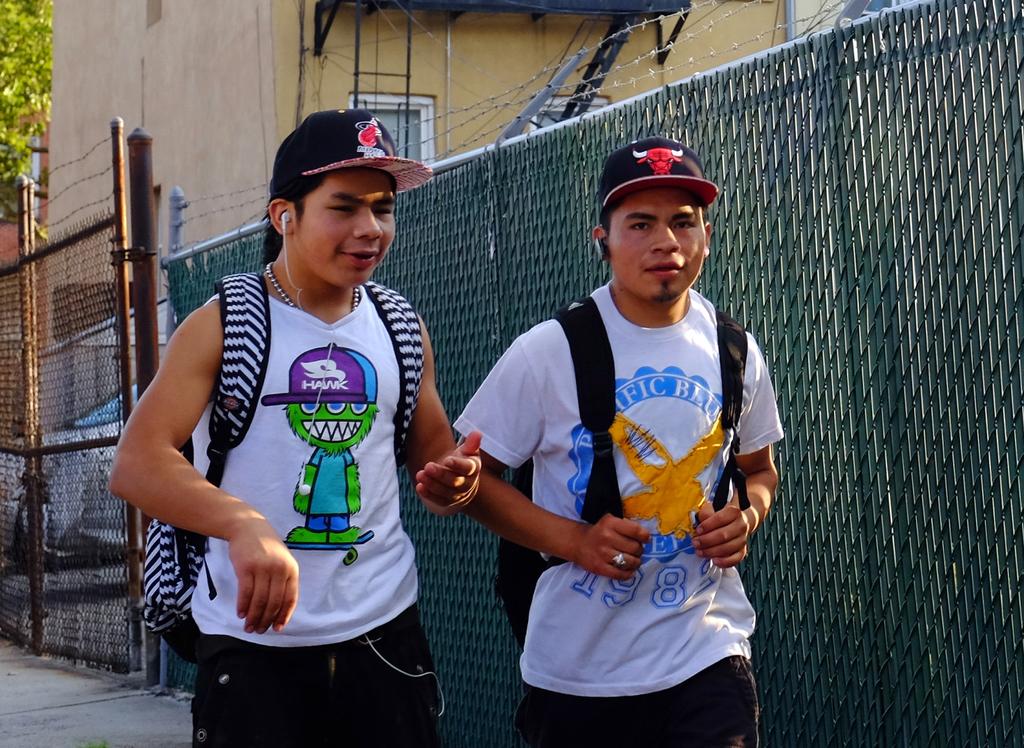What year is on the guy on the right's shirt?
Your response must be concise. 1982. Is that the letter t on the front of their caps?
Provide a succinct answer. No. 